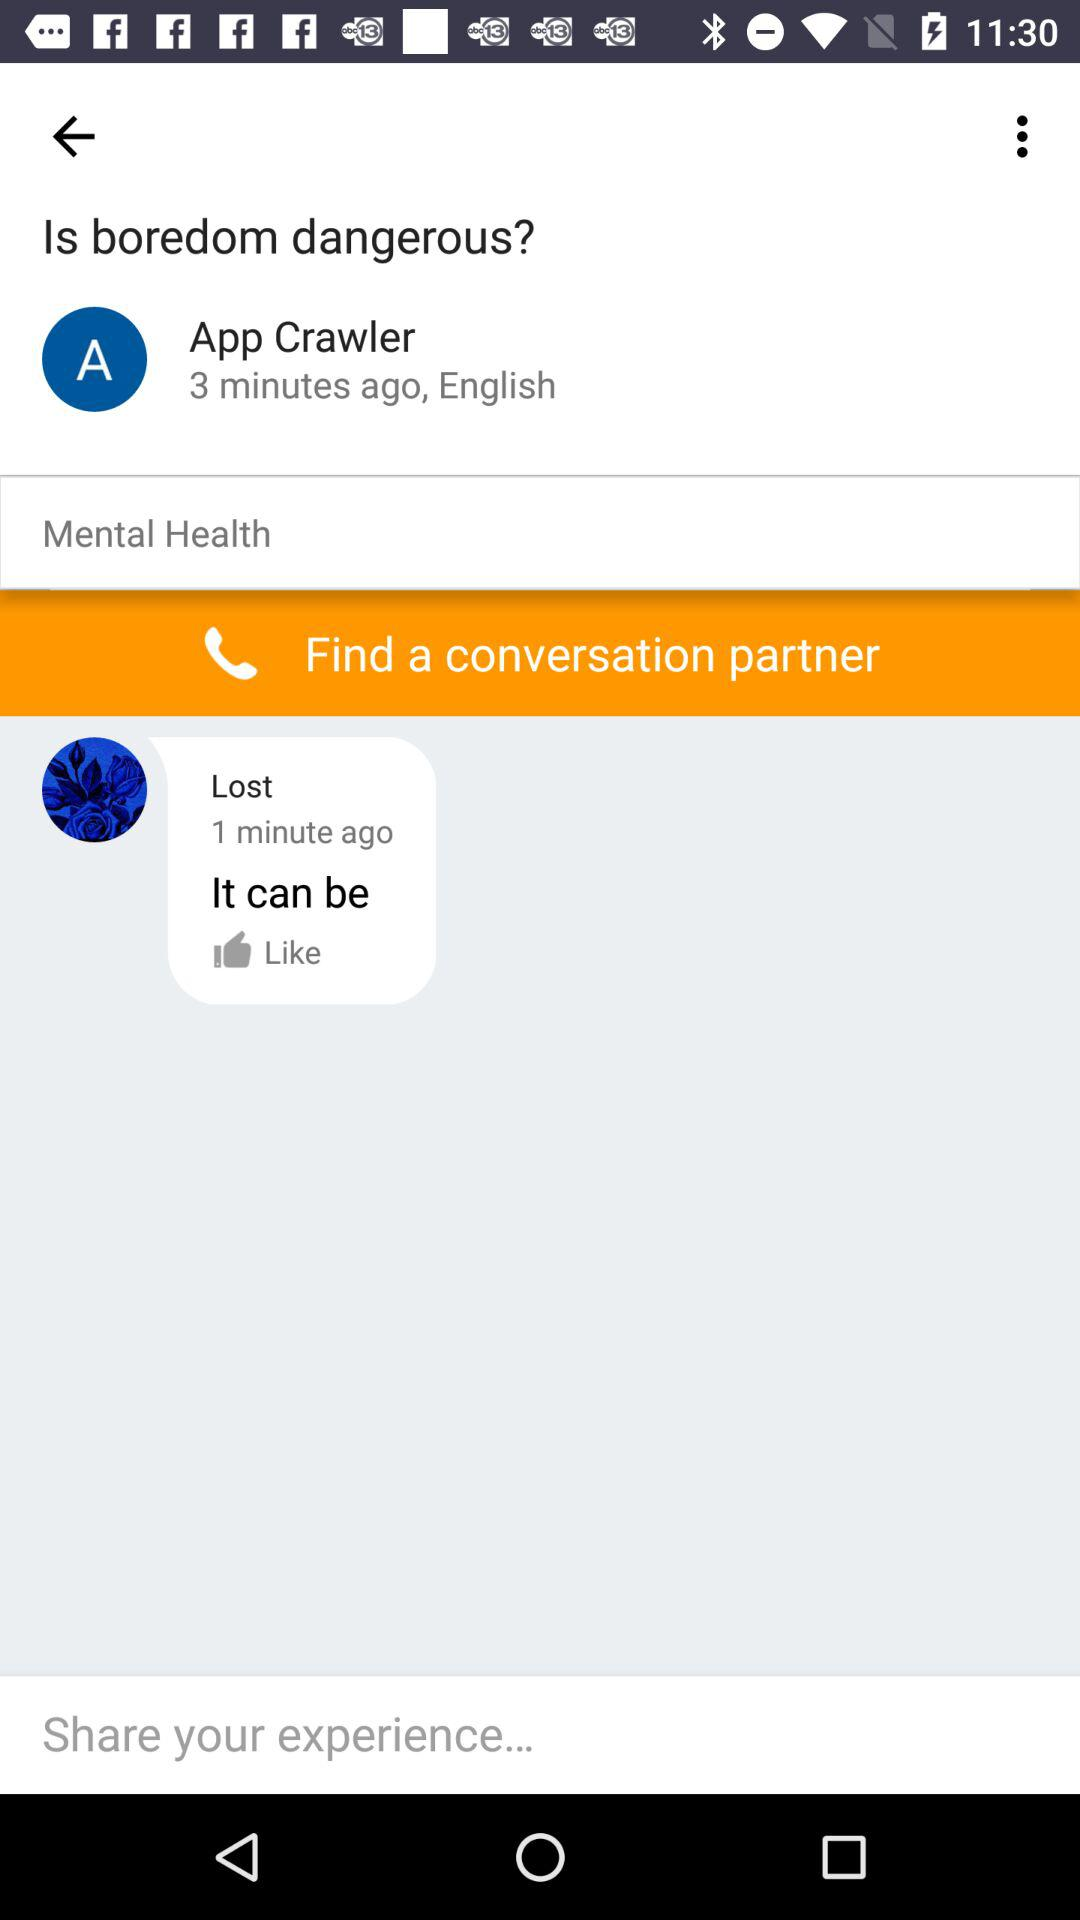What is the language? The language is English. 